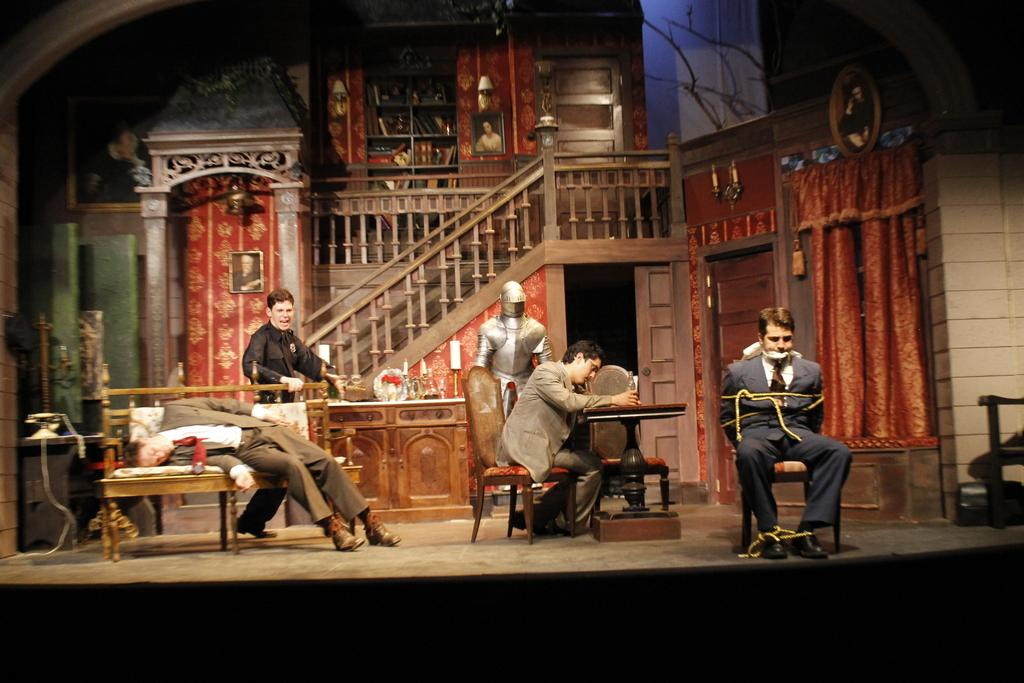What is happening in the image? There are people in the image, and they are performing a stage show. Can you describe the people in the image? Unfortunately, the facts provided do not give specific details about the people in the image. What type of performance is being given by the people in the image? The facts provided do not specify the type of performance being given. What type of bushes can be seen in the background of the stage show? There is no mention of bushes or a background in the provided facts, so we cannot answer this question. How do the pigs react to the stage show? There is no mention of pigs in the provided facts, so we cannot answer this question. 